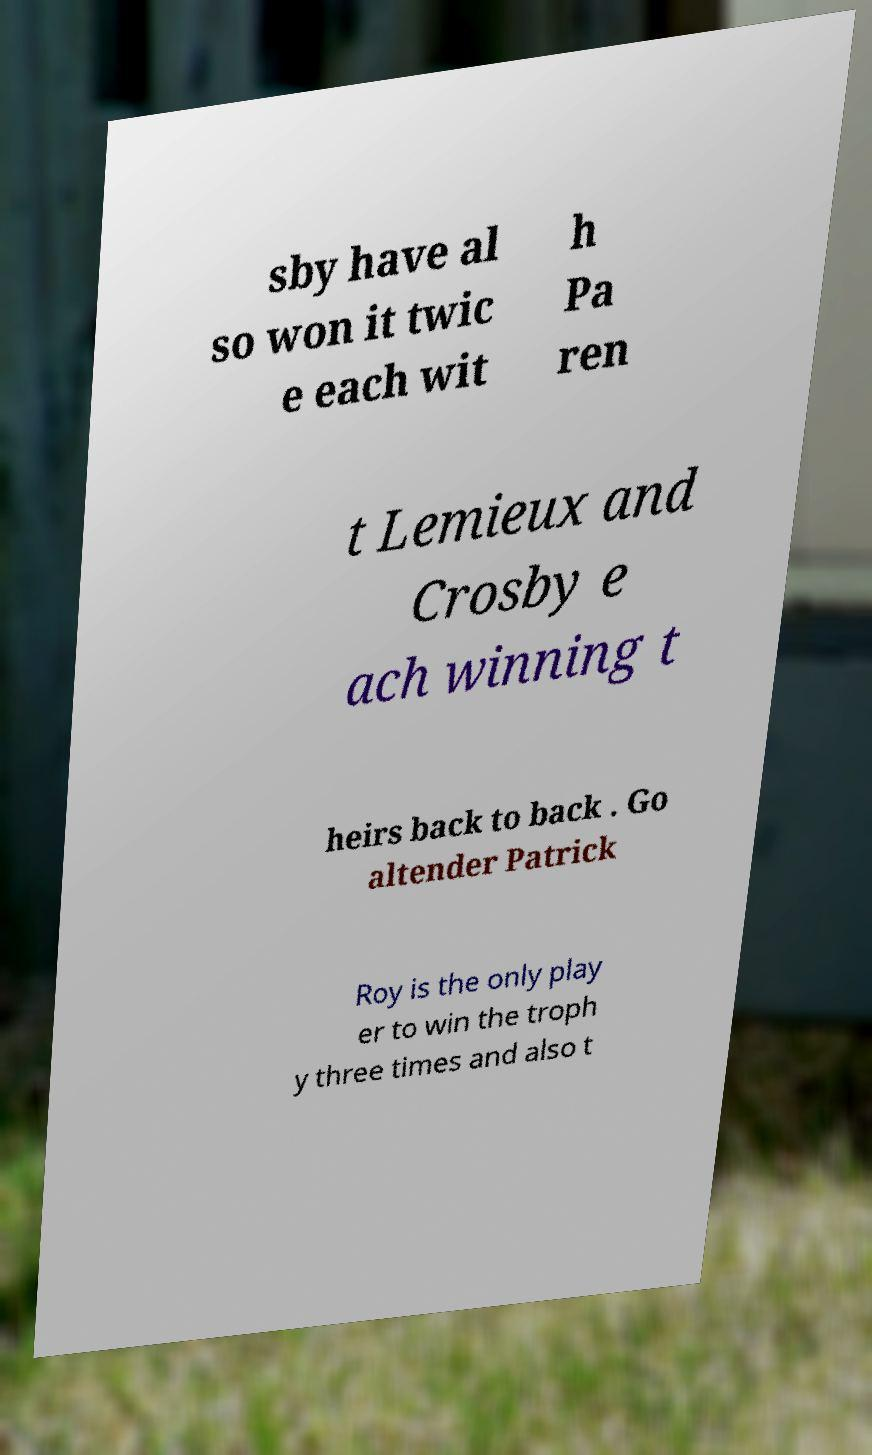There's text embedded in this image that I need extracted. Can you transcribe it verbatim? sby have al so won it twic e each wit h Pa ren t Lemieux and Crosby e ach winning t heirs back to back . Go altender Patrick Roy is the only play er to win the troph y three times and also t 